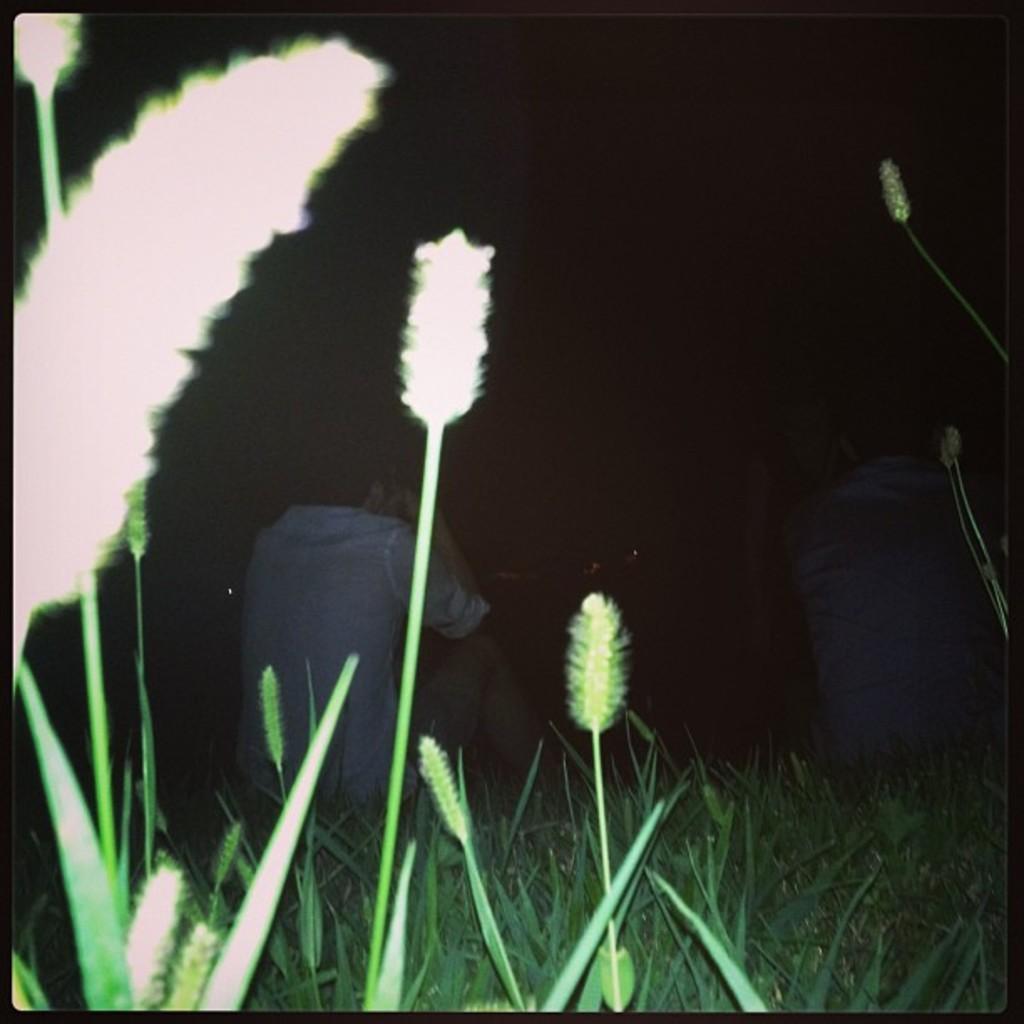Can you describe this image briefly? In the front of the image there are people and plants. In the background of the image it is dark. 